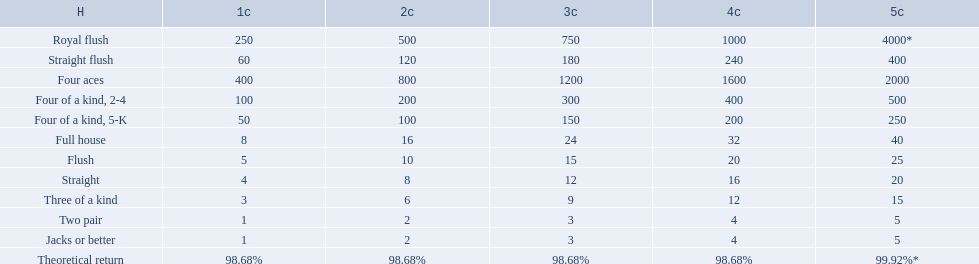Which hand is the third best hand in the card game super aces? Four aces. Which hand is the second best hand? Straight flush. Which hand had is the best hand? Royal flush. 